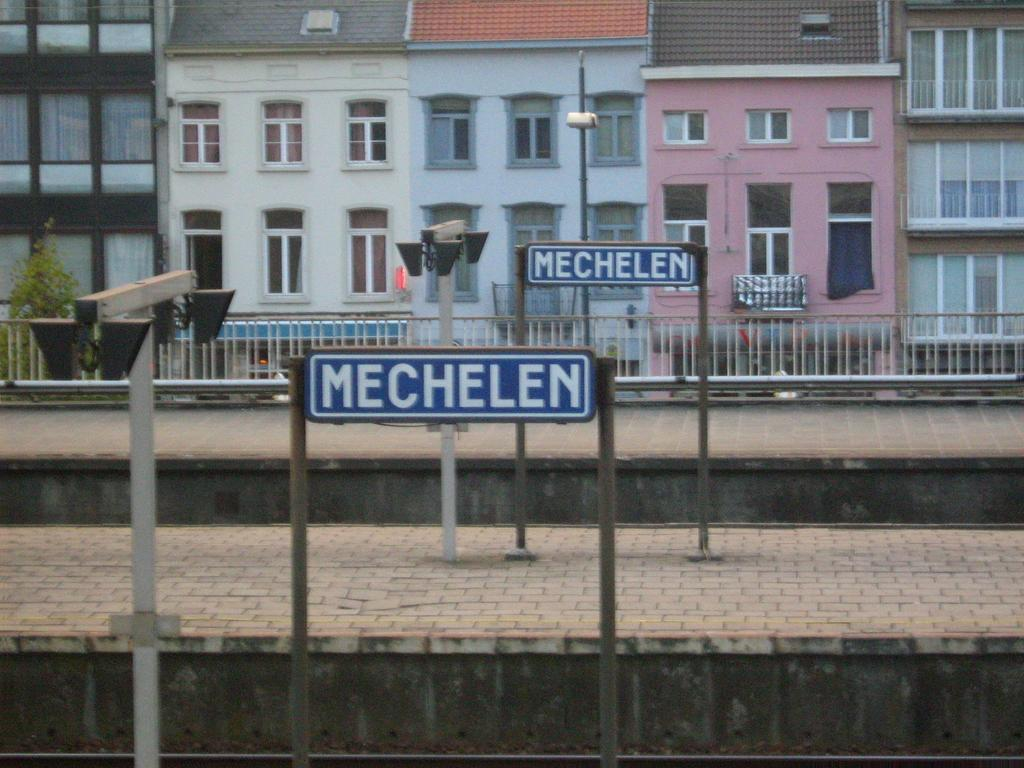What is located in the center of the image? There are poles and sign boards in the center of the image. What can be seen in the background of the image? There are buildings, windows, fences, and plants visible in the background of the image. What type of pie is being served in the image? There is no pie present in the image. Where is the bucket located in the image? There is no bucket present in the image. 